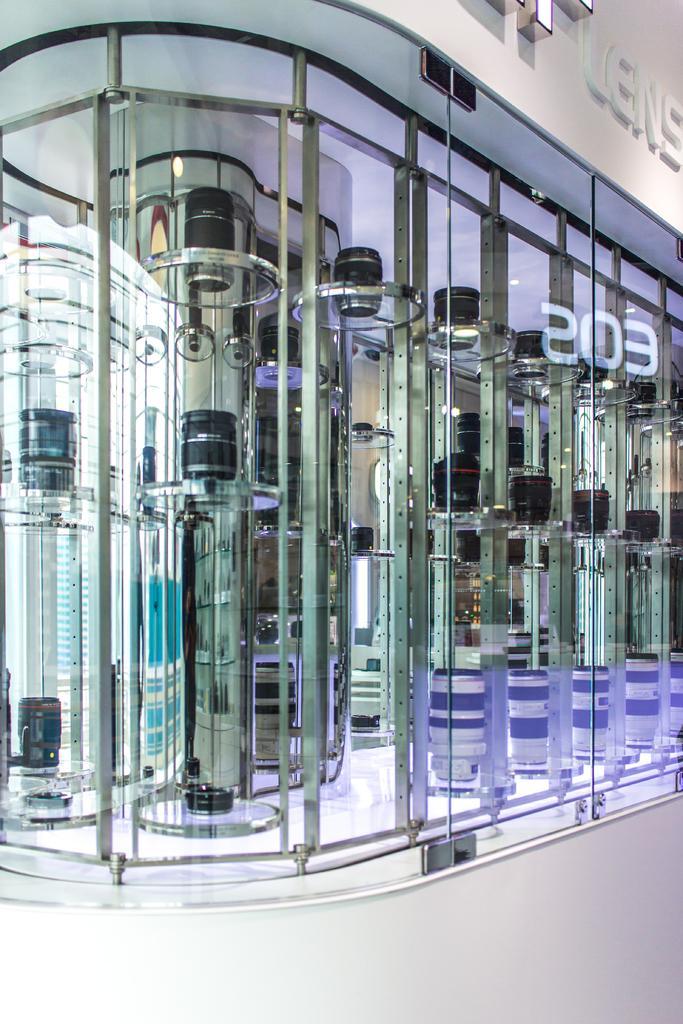Could you give a brief overview of what you see in this image? In this image there is a shop, there is a glass wall, there is wall towards the top of the image, there is text on the wall, there are objects in the shop, there is ground towards the bottom of the image. 